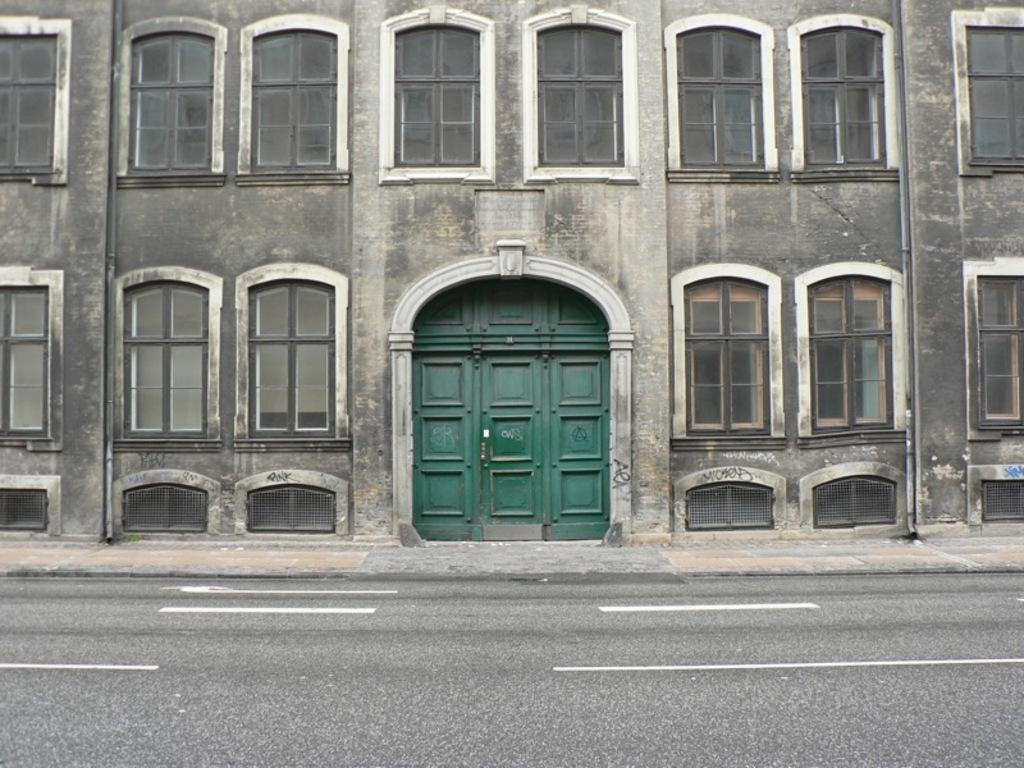In one or two sentences, can you explain what this image depicts? This image contains a building having few windows and a door to the wall of it. Before building there is a pavement. Beside it there is a road. 